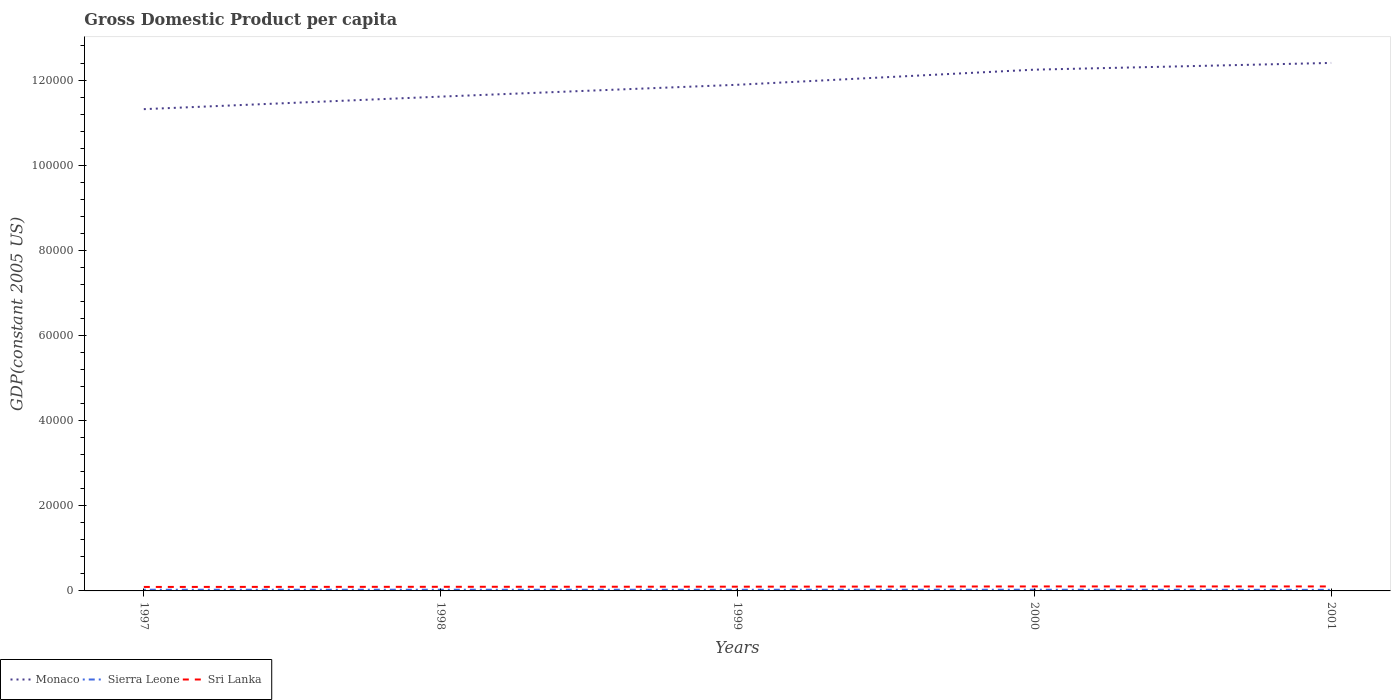Does the line corresponding to Monaco intersect with the line corresponding to Sierra Leone?
Make the answer very short. No. Across all years, what is the maximum GDP per capita in Monaco?
Your answer should be compact. 1.13e+05. In which year was the GDP per capita in Sri Lanka maximum?
Ensure brevity in your answer.  1997. What is the total GDP per capita in Sri Lanka in the graph?
Provide a succinct answer. -57.14. What is the difference between the highest and the second highest GDP per capita in Sri Lanka?
Keep it short and to the point. 117.55. What is the difference between the highest and the lowest GDP per capita in Monaco?
Your response must be concise. 2. How many lines are there?
Your answer should be very brief. 3. What is the difference between two consecutive major ticks on the Y-axis?
Your response must be concise. 2.00e+04. Are the values on the major ticks of Y-axis written in scientific E-notation?
Ensure brevity in your answer.  No. Does the graph contain any zero values?
Offer a very short reply. No. Where does the legend appear in the graph?
Keep it short and to the point. Bottom left. How many legend labels are there?
Your response must be concise. 3. How are the legend labels stacked?
Provide a short and direct response. Horizontal. What is the title of the graph?
Provide a short and direct response. Gross Domestic Product per capita. Does "Vanuatu" appear as one of the legend labels in the graph?
Keep it short and to the point. No. What is the label or title of the X-axis?
Provide a short and direct response. Years. What is the label or title of the Y-axis?
Offer a terse response. GDP(constant 2005 US). What is the GDP(constant 2005 US) of Monaco in 1997?
Make the answer very short. 1.13e+05. What is the GDP(constant 2005 US) of Sierra Leone in 1997?
Ensure brevity in your answer.  279.52. What is the GDP(constant 2005 US) of Sri Lanka in 1997?
Your answer should be compact. 934.76. What is the GDP(constant 2005 US) of Monaco in 1998?
Provide a succinct answer. 1.16e+05. What is the GDP(constant 2005 US) of Sierra Leone in 1998?
Your response must be concise. 281.94. What is the GDP(constant 2005 US) in Sri Lanka in 1998?
Provide a short and direct response. 967.42. What is the GDP(constant 2005 US) in Monaco in 1999?
Offer a terse response. 1.19e+05. What is the GDP(constant 2005 US) of Sierra Leone in 1999?
Provide a short and direct response. 271.44. What is the GDP(constant 2005 US) in Sri Lanka in 1999?
Your answer should be very brief. 994.62. What is the GDP(constant 2005 US) in Monaco in 2000?
Ensure brevity in your answer.  1.22e+05. What is the GDP(constant 2005 US) of Sierra Leone in 2000?
Your response must be concise. 281.52. What is the GDP(constant 2005 US) of Sri Lanka in 2000?
Your answer should be compact. 1051.76. What is the GDP(constant 2005 US) of Monaco in 2001?
Provide a succinct answer. 1.24e+05. What is the GDP(constant 2005 US) in Sierra Leone in 2001?
Your answer should be compact. 251.54. What is the GDP(constant 2005 US) of Sri Lanka in 2001?
Ensure brevity in your answer.  1052.31. Across all years, what is the maximum GDP(constant 2005 US) of Monaco?
Provide a succinct answer. 1.24e+05. Across all years, what is the maximum GDP(constant 2005 US) of Sierra Leone?
Provide a succinct answer. 281.94. Across all years, what is the maximum GDP(constant 2005 US) of Sri Lanka?
Give a very brief answer. 1052.31. Across all years, what is the minimum GDP(constant 2005 US) in Monaco?
Your answer should be very brief. 1.13e+05. Across all years, what is the minimum GDP(constant 2005 US) of Sierra Leone?
Offer a terse response. 251.54. Across all years, what is the minimum GDP(constant 2005 US) of Sri Lanka?
Your response must be concise. 934.76. What is the total GDP(constant 2005 US) in Monaco in the graph?
Your answer should be very brief. 5.95e+05. What is the total GDP(constant 2005 US) in Sierra Leone in the graph?
Offer a very short reply. 1365.97. What is the total GDP(constant 2005 US) of Sri Lanka in the graph?
Ensure brevity in your answer.  5000.88. What is the difference between the GDP(constant 2005 US) in Monaco in 1997 and that in 1998?
Provide a succinct answer. -2942.47. What is the difference between the GDP(constant 2005 US) in Sierra Leone in 1997 and that in 1998?
Provide a succinct answer. -2.42. What is the difference between the GDP(constant 2005 US) in Sri Lanka in 1997 and that in 1998?
Provide a short and direct response. -32.66. What is the difference between the GDP(constant 2005 US) in Monaco in 1997 and that in 1999?
Make the answer very short. -5725.95. What is the difference between the GDP(constant 2005 US) in Sierra Leone in 1997 and that in 1999?
Offer a very short reply. 8.08. What is the difference between the GDP(constant 2005 US) of Sri Lanka in 1997 and that in 1999?
Keep it short and to the point. -59.87. What is the difference between the GDP(constant 2005 US) in Monaco in 1997 and that in 2000?
Give a very brief answer. -9273.51. What is the difference between the GDP(constant 2005 US) of Sierra Leone in 1997 and that in 2000?
Offer a very short reply. -2. What is the difference between the GDP(constant 2005 US) of Sri Lanka in 1997 and that in 2000?
Ensure brevity in your answer.  -117.01. What is the difference between the GDP(constant 2005 US) of Monaco in 1997 and that in 2001?
Give a very brief answer. -1.09e+04. What is the difference between the GDP(constant 2005 US) of Sierra Leone in 1997 and that in 2001?
Ensure brevity in your answer.  27.98. What is the difference between the GDP(constant 2005 US) of Sri Lanka in 1997 and that in 2001?
Provide a short and direct response. -117.55. What is the difference between the GDP(constant 2005 US) of Monaco in 1998 and that in 1999?
Offer a very short reply. -2783.48. What is the difference between the GDP(constant 2005 US) of Sierra Leone in 1998 and that in 1999?
Give a very brief answer. 10.5. What is the difference between the GDP(constant 2005 US) of Sri Lanka in 1998 and that in 1999?
Your answer should be compact. -27.2. What is the difference between the GDP(constant 2005 US) in Monaco in 1998 and that in 2000?
Give a very brief answer. -6331.05. What is the difference between the GDP(constant 2005 US) of Sierra Leone in 1998 and that in 2000?
Your response must be concise. 0.42. What is the difference between the GDP(constant 2005 US) of Sri Lanka in 1998 and that in 2000?
Ensure brevity in your answer.  -84.34. What is the difference between the GDP(constant 2005 US) of Monaco in 1998 and that in 2001?
Your response must be concise. -7915.61. What is the difference between the GDP(constant 2005 US) in Sierra Leone in 1998 and that in 2001?
Offer a very short reply. 30.4. What is the difference between the GDP(constant 2005 US) in Sri Lanka in 1998 and that in 2001?
Your response must be concise. -84.89. What is the difference between the GDP(constant 2005 US) of Monaco in 1999 and that in 2000?
Ensure brevity in your answer.  -3547.56. What is the difference between the GDP(constant 2005 US) of Sierra Leone in 1999 and that in 2000?
Your answer should be compact. -10.08. What is the difference between the GDP(constant 2005 US) of Sri Lanka in 1999 and that in 2000?
Provide a short and direct response. -57.14. What is the difference between the GDP(constant 2005 US) of Monaco in 1999 and that in 2001?
Your response must be concise. -5132.13. What is the difference between the GDP(constant 2005 US) in Sierra Leone in 1999 and that in 2001?
Make the answer very short. 19.9. What is the difference between the GDP(constant 2005 US) of Sri Lanka in 1999 and that in 2001?
Your answer should be very brief. -57.69. What is the difference between the GDP(constant 2005 US) in Monaco in 2000 and that in 2001?
Your answer should be very brief. -1584.56. What is the difference between the GDP(constant 2005 US) in Sierra Leone in 2000 and that in 2001?
Keep it short and to the point. 29.98. What is the difference between the GDP(constant 2005 US) in Sri Lanka in 2000 and that in 2001?
Make the answer very short. -0.55. What is the difference between the GDP(constant 2005 US) of Monaco in 1997 and the GDP(constant 2005 US) of Sierra Leone in 1998?
Your response must be concise. 1.13e+05. What is the difference between the GDP(constant 2005 US) in Monaco in 1997 and the GDP(constant 2005 US) in Sri Lanka in 1998?
Offer a terse response. 1.12e+05. What is the difference between the GDP(constant 2005 US) in Sierra Leone in 1997 and the GDP(constant 2005 US) in Sri Lanka in 1998?
Provide a short and direct response. -687.9. What is the difference between the GDP(constant 2005 US) in Monaco in 1997 and the GDP(constant 2005 US) in Sierra Leone in 1999?
Offer a terse response. 1.13e+05. What is the difference between the GDP(constant 2005 US) in Monaco in 1997 and the GDP(constant 2005 US) in Sri Lanka in 1999?
Keep it short and to the point. 1.12e+05. What is the difference between the GDP(constant 2005 US) of Sierra Leone in 1997 and the GDP(constant 2005 US) of Sri Lanka in 1999?
Your answer should be compact. -715.1. What is the difference between the GDP(constant 2005 US) of Monaco in 1997 and the GDP(constant 2005 US) of Sierra Leone in 2000?
Offer a terse response. 1.13e+05. What is the difference between the GDP(constant 2005 US) of Monaco in 1997 and the GDP(constant 2005 US) of Sri Lanka in 2000?
Provide a succinct answer. 1.12e+05. What is the difference between the GDP(constant 2005 US) of Sierra Leone in 1997 and the GDP(constant 2005 US) of Sri Lanka in 2000?
Your response must be concise. -772.24. What is the difference between the GDP(constant 2005 US) in Monaco in 1997 and the GDP(constant 2005 US) in Sierra Leone in 2001?
Keep it short and to the point. 1.13e+05. What is the difference between the GDP(constant 2005 US) of Monaco in 1997 and the GDP(constant 2005 US) of Sri Lanka in 2001?
Offer a very short reply. 1.12e+05. What is the difference between the GDP(constant 2005 US) in Sierra Leone in 1997 and the GDP(constant 2005 US) in Sri Lanka in 2001?
Provide a succinct answer. -772.79. What is the difference between the GDP(constant 2005 US) of Monaco in 1998 and the GDP(constant 2005 US) of Sierra Leone in 1999?
Provide a short and direct response. 1.16e+05. What is the difference between the GDP(constant 2005 US) of Monaco in 1998 and the GDP(constant 2005 US) of Sri Lanka in 1999?
Offer a very short reply. 1.15e+05. What is the difference between the GDP(constant 2005 US) in Sierra Leone in 1998 and the GDP(constant 2005 US) in Sri Lanka in 1999?
Provide a short and direct response. -712.68. What is the difference between the GDP(constant 2005 US) of Monaco in 1998 and the GDP(constant 2005 US) of Sierra Leone in 2000?
Your answer should be very brief. 1.16e+05. What is the difference between the GDP(constant 2005 US) of Monaco in 1998 and the GDP(constant 2005 US) of Sri Lanka in 2000?
Give a very brief answer. 1.15e+05. What is the difference between the GDP(constant 2005 US) in Sierra Leone in 1998 and the GDP(constant 2005 US) in Sri Lanka in 2000?
Keep it short and to the point. -769.82. What is the difference between the GDP(constant 2005 US) of Monaco in 1998 and the GDP(constant 2005 US) of Sierra Leone in 2001?
Provide a succinct answer. 1.16e+05. What is the difference between the GDP(constant 2005 US) in Monaco in 1998 and the GDP(constant 2005 US) in Sri Lanka in 2001?
Keep it short and to the point. 1.15e+05. What is the difference between the GDP(constant 2005 US) in Sierra Leone in 1998 and the GDP(constant 2005 US) in Sri Lanka in 2001?
Your response must be concise. -770.37. What is the difference between the GDP(constant 2005 US) in Monaco in 1999 and the GDP(constant 2005 US) in Sierra Leone in 2000?
Keep it short and to the point. 1.19e+05. What is the difference between the GDP(constant 2005 US) in Monaco in 1999 and the GDP(constant 2005 US) in Sri Lanka in 2000?
Your response must be concise. 1.18e+05. What is the difference between the GDP(constant 2005 US) in Sierra Leone in 1999 and the GDP(constant 2005 US) in Sri Lanka in 2000?
Make the answer very short. -780.32. What is the difference between the GDP(constant 2005 US) in Monaco in 1999 and the GDP(constant 2005 US) in Sierra Leone in 2001?
Your answer should be very brief. 1.19e+05. What is the difference between the GDP(constant 2005 US) of Monaco in 1999 and the GDP(constant 2005 US) of Sri Lanka in 2001?
Your response must be concise. 1.18e+05. What is the difference between the GDP(constant 2005 US) of Sierra Leone in 1999 and the GDP(constant 2005 US) of Sri Lanka in 2001?
Your answer should be compact. -780.87. What is the difference between the GDP(constant 2005 US) in Monaco in 2000 and the GDP(constant 2005 US) in Sierra Leone in 2001?
Your answer should be very brief. 1.22e+05. What is the difference between the GDP(constant 2005 US) of Monaco in 2000 and the GDP(constant 2005 US) of Sri Lanka in 2001?
Keep it short and to the point. 1.21e+05. What is the difference between the GDP(constant 2005 US) in Sierra Leone in 2000 and the GDP(constant 2005 US) in Sri Lanka in 2001?
Provide a succinct answer. -770.79. What is the average GDP(constant 2005 US) of Monaco per year?
Provide a succinct answer. 1.19e+05. What is the average GDP(constant 2005 US) in Sierra Leone per year?
Provide a succinct answer. 273.19. What is the average GDP(constant 2005 US) of Sri Lanka per year?
Provide a short and direct response. 1000.18. In the year 1997, what is the difference between the GDP(constant 2005 US) of Monaco and GDP(constant 2005 US) of Sierra Leone?
Offer a very short reply. 1.13e+05. In the year 1997, what is the difference between the GDP(constant 2005 US) of Monaco and GDP(constant 2005 US) of Sri Lanka?
Give a very brief answer. 1.12e+05. In the year 1997, what is the difference between the GDP(constant 2005 US) in Sierra Leone and GDP(constant 2005 US) in Sri Lanka?
Make the answer very short. -655.24. In the year 1998, what is the difference between the GDP(constant 2005 US) in Monaco and GDP(constant 2005 US) in Sierra Leone?
Offer a terse response. 1.16e+05. In the year 1998, what is the difference between the GDP(constant 2005 US) of Monaco and GDP(constant 2005 US) of Sri Lanka?
Provide a short and direct response. 1.15e+05. In the year 1998, what is the difference between the GDP(constant 2005 US) in Sierra Leone and GDP(constant 2005 US) in Sri Lanka?
Your answer should be very brief. -685.48. In the year 1999, what is the difference between the GDP(constant 2005 US) of Monaco and GDP(constant 2005 US) of Sierra Leone?
Offer a very short reply. 1.19e+05. In the year 1999, what is the difference between the GDP(constant 2005 US) of Monaco and GDP(constant 2005 US) of Sri Lanka?
Keep it short and to the point. 1.18e+05. In the year 1999, what is the difference between the GDP(constant 2005 US) in Sierra Leone and GDP(constant 2005 US) in Sri Lanka?
Your answer should be very brief. -723.18. In the year 2000, what is the difference between the GDP(constant 2005 US) in Monaco and GDP(constant 2005 US) in Sierra Leone?
Offer a terse response. 1.22e+05. In the year 2000, what is the difference between the GDP(constant 2005 US) of Monaco and GDP(constant 2005 US) of Sri Lanka?
Offer a terse response. 1.21e+05. In the year 2000, what is the difference between the GDP(constant 2005 US) of Sierra Leone and GDP(constant 2005 US) of Sri Lanka?
Provide a short and direct response. -770.24. In the year 2001, what is the difference between the GDP(constant 2005 US) of Monaco and GDP(constant 2005 US) of Sierra Leone?
Make the answer very short. 1.24e+05. In the year 2001, what is the difference between the GDP(constant 2005 US) of Monaco and GDP(constant 2005 US) of Sri Lanka?
Give a very brief answer. 1.23e+05. In the year 2001, what is the difference between the GDP(constant 2005 US) in Sierra Leone and GDP(constant 2005 US) in Sri Lanka?
Ensure brevity in your answer.  -800.77. What is the ratio of the GDP(constant 2005 US) in Monaco in 1997 to that in 1998?
Keep it short and to the point. 0.97. What is the ratio of the GDP(constant 2005 US) in Sierra Leone in 1997 to that in 1998?
Keep it short and to the point. 0.99. What is the ratio of the GDP(constant 2005 US) of Sri Lanka in 1997 to that in 1998?
Make the answer very short. 0.97. What is the ratio of the GDP(constant 2005 US) of Monaco in 1997 to that in 1999?
Your answer should be very brief. 0.95. What is the ratio of the GDP(constant 2005 US) in Sierra Leone in 1997 to that in 1999?
Offer a very short reply. 1.03. What is the ratio of the GDP(constant 2005 US) in Sri Lanka in 1997 to that in 1999?
Your answer should be very brief. 0.94. What is the ratio of the GDP(constant 2005 US) of Monaco in 1997 to that in 2000?
Keep it short and to the point. 0.92. What is the ratio of the GDP(constant 2005 US) in Sierra Leone in 1997 to that in 2000?
Ensure brevity in your answer.  0.99. What is the ratio of the GDP(constant 2005 US) of Sri Lanka in 1997 to that in 2000?
Give a very brief answer. 0.89. What is the ratio of the GDP(constant 2005 US) of Monaco in 1997 to that in 2001?
Give a very brief answer. 0.91. What is the ratio of the GDP(constant 2005 US) in Sierra Leone in 1997 to that in 2001?
Offer a terse response. 1.11. What is the ratio of the GDP(constant 2005 US) in Sri Lanka in 1997 to that in 2001?
Your response must be concise. 0.89. What is the ratio of the GDP(constant 2005 US) in Monaco in 1998 to that in 1999?
Provide a succinct answer. 0.98. What is the ratio of the GDP(constant 2005 US) of Sierra Leone in 1998 to that in 1999?
Your response must be concise. 1.04. What is the ratio of the GDP(constant 2005 US) in Sri Lanka in 1998 to that in 1999?
Offer a terse response. 0.97. What is the ratio of the GDP(constant 2005 US) in Monaco in 1998 to that in 2000?
Make the answer very short. 0.95. What is the ratio of the GDP(constant 2005 US) of Sri Lanka in 1998 to that in 2000?
Offer a very short reply. 0.92. What is the ratio of the GDP(constant 2005 US) of Monaco in 1998 to that in 2001?
Offer a very short reply. 0.94. What is the ratio of the GDP(constant 2005 US) of Sierra Leone in 1998 to that in 2001?
Give a very brief answer. 1.12. What is the ratio of the GDP(constant 2005 US) of Sri Lanka in 1998 to that in 2001?
Your response must be concise. 0.92. What is the ratio of the GDP(constant 2005 US) of Monaco in 1999 to that in 2000?
Give a very brief answer. 0.97. What is the ratio of the GDP(constant 2005 US) in Sierra Leone in 1999 to that in 2000?
Your response must be concise. 0.96. What is the ratio of the GDP(constant 2005 US) in Sri Lanka in 1999 to that in 2000?
Your answer should be very brief. 0.95. What is the ratio of the GDP(constant 2005 US) in Monaco in 1999 to that in 2001?
Provide a succinct answer. 0.96. What is the ratio of the GDP(constant 2005 US) of Sierra Leone in 1999 to that in 2001?
Your response must be concise. 1.08. What is the ratio of the GDP(constant 2005 US) of Sri Lanka in 1999 to that in 2001?
Make the answer very short. 0.95. What is the ratio of the GDP(constant 2005 US) in Monaco in 2000 to that in 2001?
Keep it short and to the point. 0.99. What is the ratio of the GDP(constant 2005 US) in Sierra Leone in 2000 to that in 2001?
Ensure brevity in your answer.  1.12. What is the ratio of the GDP(constant 2005 US) in Sri Lanka in 2000 to that in 2001?
Give a very brief answer. 1. What is the difference between the highest and the second highest GDP(constant 2005 US) of Monaco?
Your response must be concise. 1584.56. What is the difference between the highest and the second highest GDP(constant 2005 US) in Sierra Leone?
Provide a succinct answer. 0.42. What is the difference between the highest and the second highest GDP(constant 2005 US) in Sri Lanka?
Give a very brief answer. 0.55. What is the difference between the highest and the lowest GDP(constant 2005 US) in Monaco?
Your response must be concise. 1.09e+04. What is the difference between the highest and the lowest GDP(constant 2005 US) of Sierra Leone?
Keep it short and to the point. 30.4. What is the difference between the highest and the lowest GDP(constant 2005 US) of Sri Lanka?
Provide a succinct answer. 117.55. 